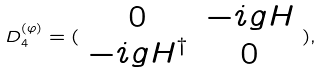Convert formula to latex. <formula><loc_0><loc_0><loc_500><loc_500>D _ { 4 } ^ { ( \varphi ) } = ( \begin{array} { c c } 0 & - i g H \\ - i g H ^ { \dagger } & 0 \end{array} ) ,</formula> 